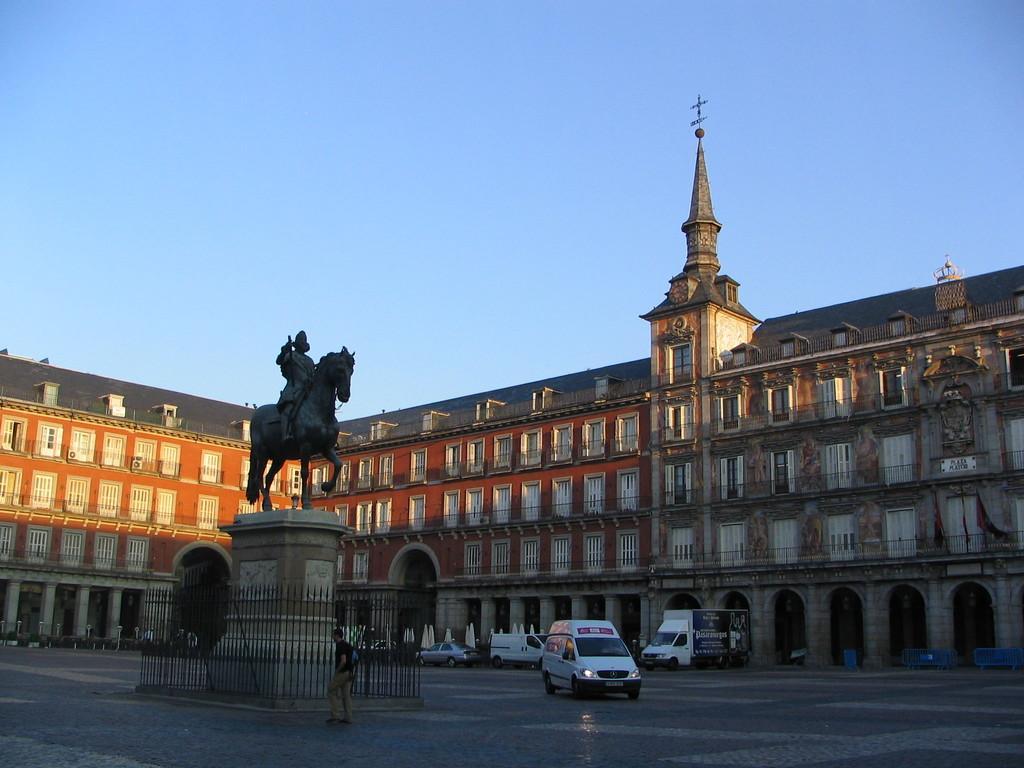Please provide a concise description of this image. In this picture we can observe a statue placed on the pillar. Around this pillar there is a railing. We can observe a man walking here. There some vehicles on this path. We can observe a large building. In the background there is a sky. 